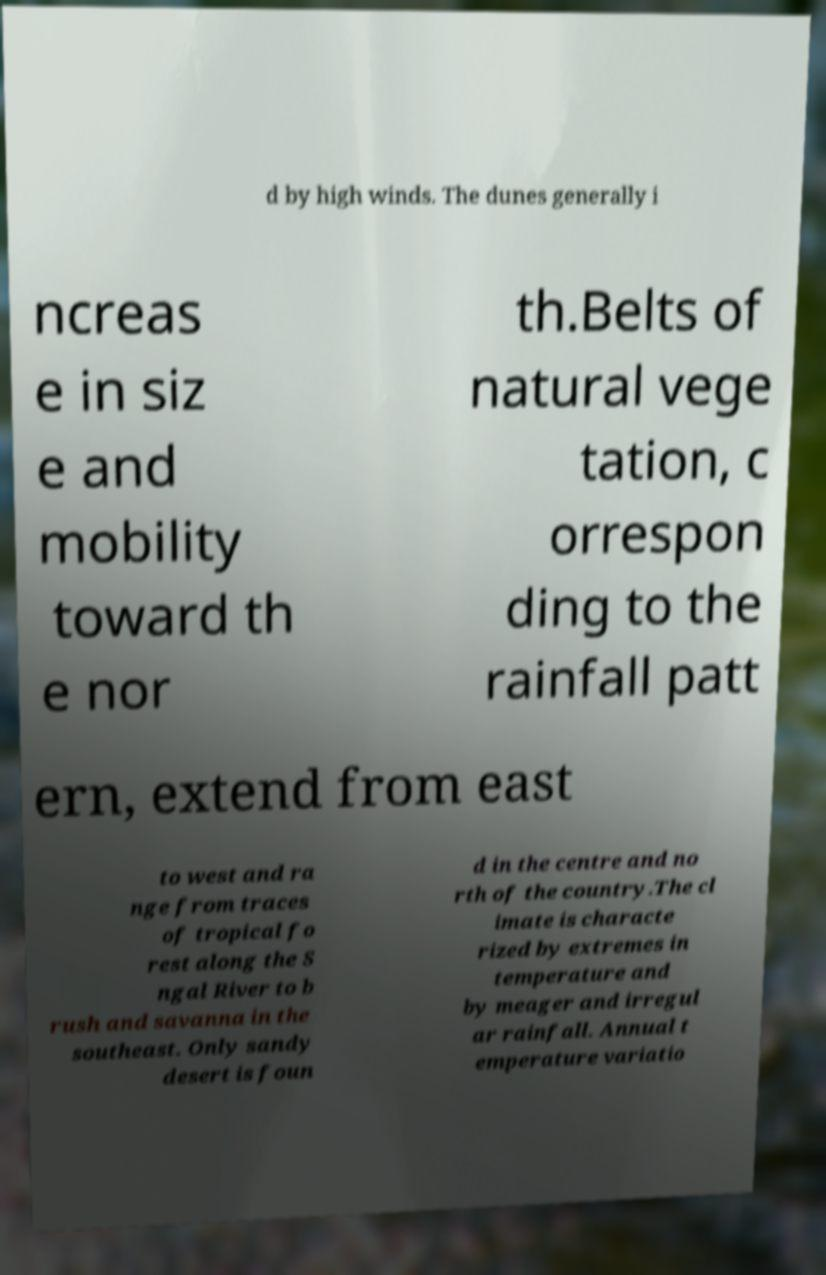What messages or text are displayed in this image? I need them in a readable, typed format. d by high winds. The dunes generally i ncreas e in siz e and mobility toward th e nor th.Belts of natural vege tation, c orrespon ding to the rainfall patt ern, extend from east to west and ra nge from traces of tropical fo rest along the S ngal River to b rush and savanna in the southeast. Only sandy desert is foun d in the centre and no rth of the country.The cl imate is characte rized by extremes in temperature and by meager and irregul ar rainfall. Annual t emperature variatio 